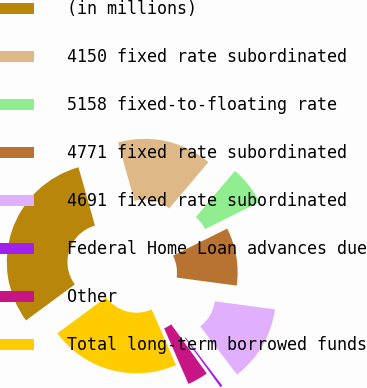<chart> <loc_0><loc_0><loc_500><loc_500><pie_chart><fcel>(in millions)<fcel>4150 fixed rate subordinated<fcel>5158 fixed-to-floating rate<fcel>4771 fixed rate subordinated<fcel>4691 fixed rate subordinated<fcel>Federal Home Loan advances due<fcel>Other<fcel>Total long-term borrowed funds<nl><fcel>30.73%<fcel>15.56%<fcel>6.45%<fcel>9.49%<fcel>12.52%<fcel>0.38%<fcel>3.42%<fcel>21.45%<nl></chart> 